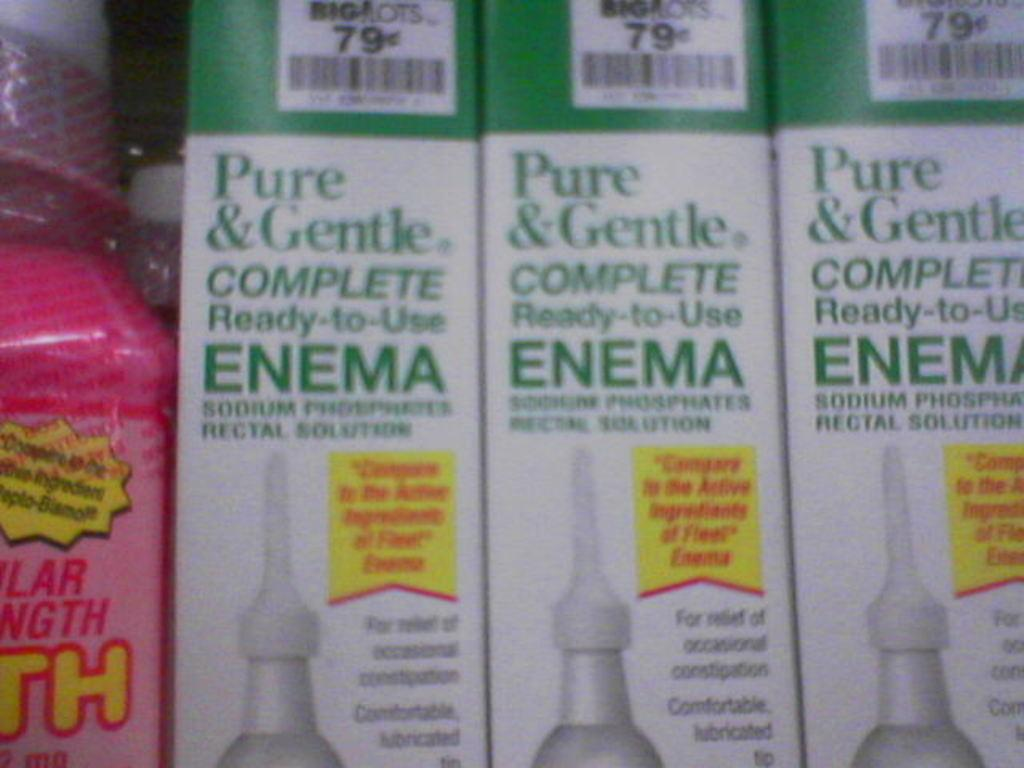<image>
Provide a brief description of the given image. Pure & Gentle complete Ready to use enema green and white package 79 cents. 